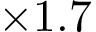Convert formula to latex. <formula><loc_0><loc_0><loc_500><loc_500>\times 1 . 7</formula> 